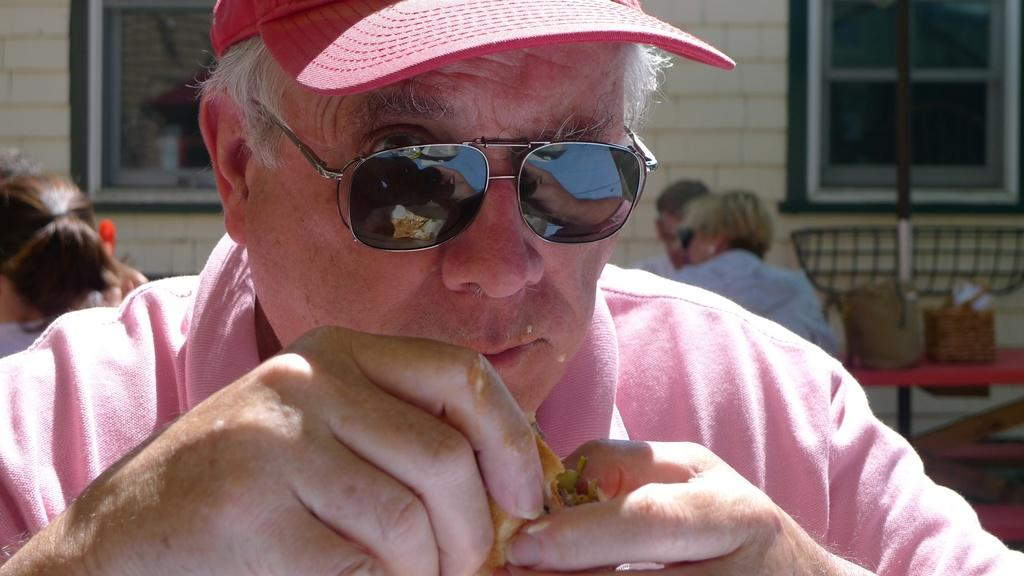What can be seen on the person's head in the image? The person is wearing a hat in the image. What is the person holding in the image? The person is holding a food item in the image. What is happening in the background of the image? There is a group of people sitting and a table in the background of the image. What can be seen outside the building in the image? There are windows of a building in the background of the image. What type of insurance policy is the person discussing with the group in the image? There is no indication in the image that the person is discussing insurance with the group. 